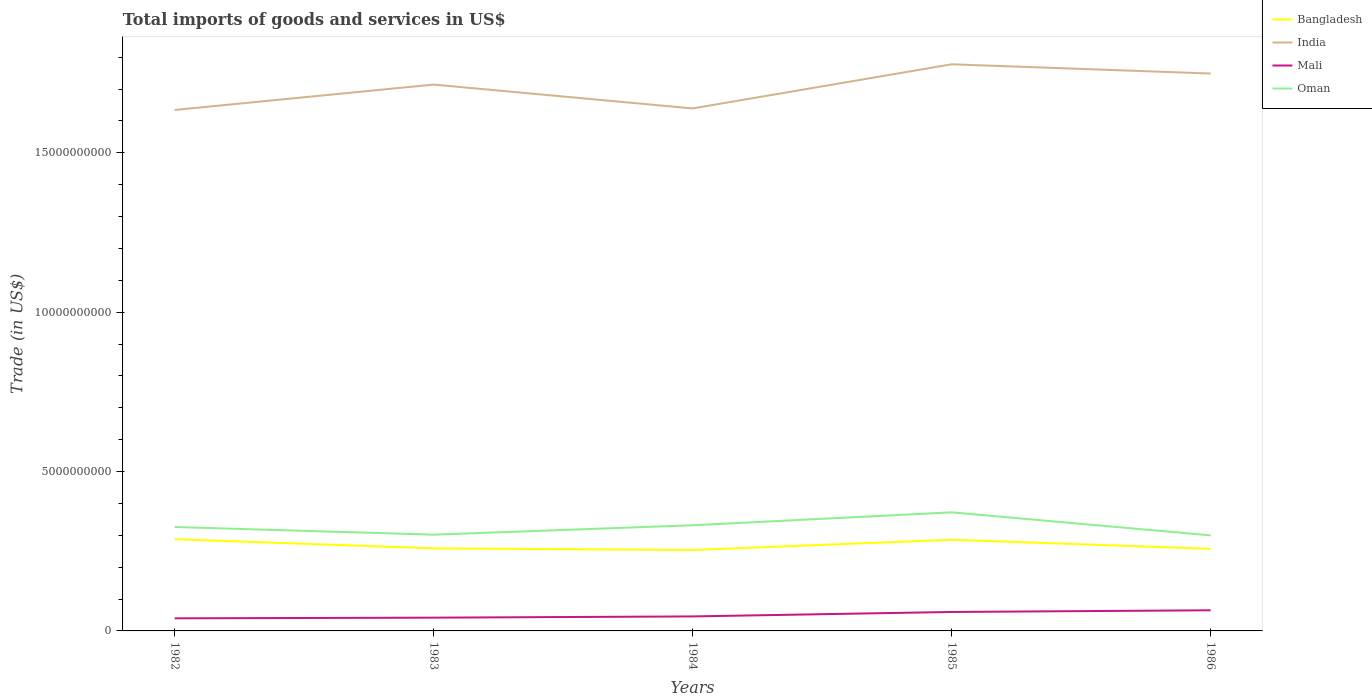Is the number of lines equal to the number of legend labels?
Offer a very short reply. Yes. Across all years, what is the maximum total imports of goods and services in Oman?
Offer a terse response. 3.00e+09. In which year was the total imports of goods and services in Mali maximum?
Your answer should be compact. 1982. What is the total total imports of goods and services in Oman in the graph?
Provide a short and direct response. 2.40e+08. What is the difference between the highest and the second highest total imports of goods and services in Mali?
Give a very brief answer. 2.52e+08. Is the total imports of goods and services in Oman strictly greater than the total imports of goods and services in Mali over the years?
Your answer should be very brief. No. Are the values on the major ticks of Y-axis written in scientific E-notation?
Your response must be concise. No. Where does the legend appear in the graph?
Your response must be concise. Top right. How many legend labels are there?
Provide a short and direct response. 4. What is the title of the graph?
Your answer should be compact. Total imports of goods and services in US$. What is the label or title of the Y-axis?
Provide a succinct answer. Trade (in US$). What is the Trade (in US$) of Bangladesh in 1982?
Your answer should be compact. 2.88e+09. What is the Trade (in US$) in India in 1982?
Your answer should be compact. 1.63e+1. What is the Trade (in US$) in Mali in 1982?
Your answer should be compact. 3.95e+08. What is the Trade (in US$) in Oman in 1982?
Ensure brevity in your answer.  3.26e+09. What is the Trade (in US$) of Bangladesh in 1983?
Your answer should be very brief. 2.59e+09. What is the Trade (in US$) in India in 1983?
Keep it short and to the point. 1.71e+1. What is the Trade (in US$) of Mali in 1983?
Keep it short and to the point. 4.16e+08. What is the Trade (in US$) of Oman in 1983?
Your answer should be compact. 3.02e+09. What is the Trade (in US$) in Bangladesh in 1984?
Your response must be concise. 2.54e+09. What is the Trade (in US$) of India in 1984?
Provide a succinct answer. 1.64e+1. What is the Trade (in US$) in Mali in 1984?
Offer a very short reply. 4.55e+08. What is the Trade (in US$) of Oman in 1984?
Provide a short and direct response. 3.32e+09. What is the Trade (in US$) in Bangladesh in 1985?
Keep it short and to the point. 2.86e+09. What is the Trade (in US$) in India in 1985?
Ensure brevity in your answer.  1.78e+1. What is the Trade (in US$) in Mali in 1985?
Your answer should be compact. 5.95e+08. What is the Trade (in US$) of Oman in 1985?
Give a very brief answer. 3.72e+09. What is the Trade (in US$) in Bangladesh in 1986?
Provide a succinct answer. 2.58e+09. What is the Trade (in US$) of India in 1986?
Provide a short and direct response. 1.75e+1. What is the Trade (in US$) of Mali in 1986?
Offer a terse response. 6.47e+08. What is the Trade (in US$) in Oman in 1986?
Give a very brief answer. 3.00e+09. Across all years, what is the maximum Trade (in US$) of Bangladesh?
Keep it short and to the point. 2.88e+09. Across all years, what is the maximum Trade (in US$) in India?
Keep it short and to the point. 1.78e+1. Across all years, what is the maximum Trade (in US$) in Mali?
Make the answer very short. 6.47e+08. Across all years, what is the maximum Trade (in US$) in Oman?
Ensure brevity in your answer.  3.72e+09. Across all years, what is the minimum Trade (in US$) of Bangladesh?
Provide a short and direct response. 2.54e+09. Across all years, what is the minimum Trade (in US$) of India?
Your answer should be compact. 1.63e+1. Across all years, what is the minimum Trade (in US$) of Mali?
Offer a terse response. 3.95e+08. Across all years, what is the minimum Trade (in US$) in Oman?
Ensure brevity in your answer.  3.00e+09. What is the total Trade (in US$) of Bangladesh in the graph?
Make the answer very short. 1.34e+1. What is the total Trade (in US$) of India in the graph?
Provide a short and direct response. 8.51e+1. What is the total Trade (in US$) in Mali in the graph?
Keep it short and to the point. 2.51e+09. What is the total Trade (in US$) in Oman in the graph?
Offer a very short reply. 1.63e+1. What is the difference between the Trade (in US$) of Bangladesh in 1982 and that in 1983?
Provide a short and direct response. 2.86e+08. What is the difference between the Trade (in US$) of India in 1982 and that in 1983?
Provide a succinct answer. -7.97e+08. What is the difference between the Trade (in US$) in Mali in 1982 and that in 1983?
Keep it short and to the point. -2.11e+07. What is the difference between the Trade (in US$) in Oman in 1982 and that in 1983?
Provide a short and direct response. 2.40e+08. What is the difference between the Trade (in US$) in Bangladesh in 1982 and that in 1984?
Ensure brevity in your answer.  3.39e+08. What is the difference between the Trade (in US$) in India in 1982 and that in 1984?
Make the answer very short. -4.78e+07. What is the difference between the Trade (in US$) in Mali in 1982 and that in 1984?
Your answer should be compact. -5.95e+07. What is the difference between the Trade (in US$) of Oman in 1982 and that in 1984?
Provide a short and direct response. -5.50e+07. What is the difference between the Trade (in US$) in Bangladesh in 1982 and that in 1985?
Your response must be concise. 1.73e+07. What is the difference between the Trade (in US$) of India in 1982 and that in 1985?
Your response must be concise. -1.43e+09. What is the difference between the Trade (in US$) in Mali in 1982 and that in 1985?
Provide a succinct answer. -1.99e+08. What is the difference between the Trade (in US$) of Oman in 1982 and that in 1985?
Keep it short and to the point. -4.60e+08. What is the difference between the Trade (in US$) in Bangladesh in 1982 and that in 1986?
Your answer should be very brief. 3.00e+08. What is the difference between the Trade (in US$) of India in 1982 and that in 1986?
Provide a succinct answer. -1.14e+09. What is the difference between the Trade (in US$) of Mali in 1982 and that in 1986?
Offer a very short reply. -2.52e+08. What is the difference between the Trade (in US$) of Oman in 1982 and that in 1986?
Give a very brief answer. 2.62e+08. What is the difference between the Trade (in US$) in Bangladesh in 1983 and that in 1984?
Your response must be concise. 5.25e+07. What is the difference between the Trade (in US$) in India in 1983 and that in 1984?
Give a very brief answer. 7.49e+08. What is the difference between the Trade (in US$) of Mali in 1983 and that in 1984?
Your response must be concise. -3.83e+07. What is the difference between the Trade (in US$) of Oman in 1983 and that in 1984?
Your response must be concise. -2.95e+08. What is the difference between the Trade (in US$) in Bangladesh in 1983 and that in 1985?
Ensure brevity in your answer.  -2.69e+08. What is the difference between the Trade (in US$) in India in 1983 and that in 1985?
Ensure brevity in your answer.  -6.37e+08. What is the difference between the Trade (in US$) in Mali in 1983 and that in 1985?
Your response must be concise. -1.78e+08. What is the difference between the Trade (in US$) in Oman in 1983 and that in 1985?
Your response must be concise. -7.01e+08. What is the difference between the Trade (in US$) in Bangladesh in 1983 and that in 1986?
Your response must be concise. 1.37e+07. What is the difference between the Trade (in US$) of India in 1983 and that in 1986?
Keep it short and to the point. -3.46e+08. What is the difference between the Trade (in US$) of Mali in 1983 and that in 1986?
Provide a succinct answer. -2.31e+08. What is the difference between the Trade (in US$) of Oman in 1983 and that in 1986?
Offer a terse response. 2.22e+07. What is the difference between the Trade (in US$) in Bangladesh in 1984 and that in 1985?
Provide a succinct answer. -3.22e+08. What is the difference between the Trade (in US$) of India in 1984 and that in 1985?
Provide a short and direct response. -1.39e+09. What is the difference between the Trade (in US$) in Mali in 1984 and that in 1985?
Your answer should be compact. -1.40e+08. What is the difference between the Trade (in US$) in Oman in 1984 and that in 1985?
Provide a short and direct response. -4.05e+08. What is the difference between the Trade (in US$) of Bangladesh in 1984 and that in 1986?
Provide a succinct answer. -3.88e+07. What is the difference between the Trade (in US$) of India in 1984 and that in 1986?
Offer a terse response. -1.10e+09. What is the difference between the Trade (in US$) in Mali in 1984 and that in 1986?
Ensure brevity in your answer.  -1.93e+08. What is the difference between the Trade (in US$) of Oman in 1984 and that in 1986?
Your response must be concise. 3.18e+08. What is the difference between the Trade (in US$) in Bangladesh in 1985 and that in 1986?
Ensure brevity in your answer.  2.83e+08. What is the difference between the Trade (in US$) in India in 1985 and that in 1986?
Offer a very short reply. 2.90e+08. What is the difference between the Trade (in US$) of Mali in 1985 and that in 1986?
Ensure brevity in your answer.  -5.28e+07. What is the difference between the Trade (in US$) of Oman in 1985 and that in 1986?
Keep it short and to the point. 7.23e+08. What is the difference between the Trade (in US$) of Bangladesh in 1982 and the Trade (in US$) of India in 1983?
Give a very brief answer. -1.43e+1. What is the difference between the Trade (in US$) in Bangladesh in 1982 and the Trade (in US$) in Mali in 1983?
Ensure brevity in your answer.  2.46e+09. What is the difference between the Trade (in US$) of Bangladesh in 1982 and the Trade (in US$) of Oman in 1983?
Your answer should be compact. -1.42e+08. What is the difference between the Trade (in US$) of India in 1982 and the Trade (in US$) of Mali in 1983?
Provide a short and direct response. 1.59e+1. What is the difference between the Trade (in US$) of India in 1982 and the Trade (in US$) of Oman in 1983?
Keep it short and to the point. 1.33e+1. What is the difference between the Trade (in US$) of Mali in 1982 and the Trade (in US$) of Oman in 1983?
Your answer should be very brief. -2.62e+09. What is the difference between the Trade (in US$) of Bangladesh in 1982 and the Trade (in US$) of India in 1984?
Keep it short and to the point. -1.35e+1. What is the difference between the Trade (in US$) of Bangladesh in 1982 and the Trade (in US$) of Mali in 1984?
Give a very brief answer. 2.42e+09. What is the difference between the Trade (in US$) in Bangladesh in 1982 and the Trade (in US$) in Oman in 1984?
Your answer should be compact. -4.38e+08. What is the difference between the Trade (in US$) in India in 1982 and the Trade (in US$) in Mali in 1984?
Provide a short and direct response. 1.59e+1. What is the difference between the Trade (in US$) in India in 1982 and the Trade (in US$) in Oman in 1984?
Your answer should be very brief. 1.30e+1. What is the difference between the Trade (in US$) of Mali in 1982 and the Trade (in US$) of Oman in 1984?
Provide a short and direct response. -2.92e+09. What is the difference between the Trade (in US$) in Bangladesh in 1982 and the Trade (in US$) in India in 1985?
Offer a terse response. -1.49e+1. What is the difference between the Trade (in US$) in Bangladesh in 1982 and the Trade (in US$) in Mali in 1985?
Ensure brevity in your answer.  2.28e+09. What is the difference between the Trade (in US$) of Bangladesh in 1982 and the Trade (in US$) of Oman in 1985?
Provide a short and direct response. -8.43e+08. What is the difference between the Trade (in US$) of India in 1982 and the Trade (in US$) of Mali in 1985?
Offer a terse response. 1.57e+1. What is the difference between the Trade (in US$) of India in 1982 and the Trade (in US$) of Oman in 1985?
Provide a short and direct response. 1.26e+1. What is the difference between the Trade (in US$) of Mali in 1982 and the Trade (in US$) of Oman in 1985?
Your response must be concise. -3.33e+09. What is the difference between the Trade (in US$) of Bangladesh in 1982 and the Trade (in US$) of India in 1986?
Offer a very short reply. -1.46e+1. What is the difference between the Trade (in US$) of Bangladesh in 1982 and the Trade (in US$) of Mali in 1986?
Offer a terse response. 2.23e+09. What is the difference between the Trade (in US$) of Bangladesh in 1982 and the Trade (in US$) of Oman in 1986?
Your answer should be very brief. -1.20e+08. What is the difference between the Trade (in US$) of India in 1982 and the Trade (in US$) of Mali in 1986?
Ensure brevity in your answer.  1.57e+1. What is the difference between the Trade (in US$) in India in 1982 and the Trade (in US$) in Oman in 1986?
Make the answer very short. 1.33e+1. What is the difference between the Trade (in US$) of Mali in 1982 and the Trade (in US$) of Oman in 1986?
Your response must be concise. -2.60e+09. What is the difference between the Trade (in US$) in Bangladesh in 1983 and the Trade (in US$) in India in 1984?
Keep it short and to the point. -1.38e+1. What is the difference between the Trade (in US$) in Bangladesh in 1983 and the Trade (in US$) in Mali in 1984?
Give a very brief answer. 2.14e+09. What is the difference between the Trade (in US$) in Bangladesh in 1983 and the Trade (in US$) in Oman in 1984?
Provide a succinct answer. -7.24e+08. What is the difference between the Trade (in US$) in India in 1983 and the Trade (in US$) in Mali in 1984?
Provide a short and direct response. 1.67e+1. What is the difference between the Trade (in US$) in India in 1983 and the Trade (in US$) in Oman in 1984?
Your response must be concise. 1.38e+1. What is the difference between the Trade (in US$) in Mali in 1983 and the Trade (in US$) in Oman in 1984?
Ensure brevity in your answer.  -2.90e+09. What is the difference between the Trade (in US$) in Bangladesh in 1983 and the Trade (in US$) in India in 1985?
Provide a succinct answer. -1.52e+1. What is the difference between the Trade (in US$) of Bangladesh in 1983 and the Trade (in US$) of Mali in 1985?
Make the answer very short. 2.00e+09. What is the difference between the Trade (in US$) in Bangladesh in 1983 and the Trade (in US$) in Oman in 1985?
Your answer should be very brief. -1.13e+09. What is the difference between the Trade (in US$) of India in 1983 and the Trade (in US$) of Mali in 1985?
Your response must be concise. 1.65e+1. What is the difference between the Trade (in US$) of India in 1983 and the Trade (in US$) of Oman in 1985?
Your response must be concise. 1.34e+1. What is the difference between the Trade (in US$) of Mali in 1983 and the Trade (in US$) of Oman in 1985?
Make the answer very short. -3.30e+09. What is the difference between the Trade (in US$) in Bangladesh in 1983 and the Trade (in US$) in India in 1986?
Give a very brief answer. -1.49e+1. What is the difference between the Trade (in US$) in Bangladesh in 1983 and the Trade (in US$) in Mali in 1986?
Your answer should be very brief. 1.94e+09. What is the difference between the Trade (in US$) of Bangladesh in 1983 and the Trade (in US$) of Oman in 1986?
Make the answer very short. -4.07e+08. What is the difference between the Trade (in US$) of India in 1983 and the Trade (in US$) of Mali in 1986?
Give a very brief answer. 1.65e+1. What is the difference between the Trade (in US$) of India in 1983 and the Trade (in US$) of Oman in 1986?
Offer a terse response. 1.41e+1. What is the difference between the Trade (in US$) in Mali in 1983 and the Trade (in US$) in Oman in 1986?
Ensure brevity in your answer.  -2.58e+09. What is the difference between the Trade (in US$) in Bangladesh in 1984 and the Trade (in US$) in India in 1985?
Keep it short and to the point. -1.52e+1. What is the difference between the Trade (in US$) of Bangladesh in 1984 and the Trade (in US$) of Mali in 1985?
Offer a terse response. 1.94e+09. What is the difference between the Trade (in US$) in Bangladesh in 1984 and the Trade (in US$) in Oman in 1985?
Give a very brief answer. -1.18e+09. What is the difference between the Trade (in US$) of India in 1984 and the Trade (in US$) of Mali in 1985?
Provide a succinct answer. 1.58e+1. What is the difference between the Trade (in US$) in India in 1984 and the Trade (in US$) in Oman in 1985?
Provide a short and direct response. 1.27e+1. What is the difference between the Trade (in US$) in Mali in 1984 and the Trade (in US$) in Oman in 1985?
Give a very brief answer. -3.27e+09. What is the difference between the Trade (in US$) of Bangladesh in 1984 and the Trade (in US$) of India in 1986?
Provide a succinct answer. -1.49e+1. What is the difference between the Trade (in US$) in Bangladesh in 1984 and the Trade (in US$) in Mali in 1986?
Keep it short and to the point. 1.89e+09. What is the difference between the Trade (in US$) of Bangladesh in 1984 and the Trade (in US$) of Oman in 1986?
Your answer should be compact. -4.59e+08. What is the difference between the Trade (in US$) in India in 1984 and the Trade (in US$) in Mali in 1986?
Provide a succinct answer. 1.57e+1. What is the difference between the Trade (in US$) in India in 1984 and the Trade (in US$) in Oman in 1986?
Offer a very short reply. 1.34e+1. What is the difference between the Trade (in US$) in Mali in 1984 and the Trade (in US$) in Oman in 1986?
Provide a succinct answer. -2.54e+09. What is the difference between the Trade (in US$) of Bangladesh in 1985 and the Trade (in US$) of India in 1986?
Ensure brevity in your answer.  -1.46e+1. What is the difference between the Trade (in US$) in Bangladesh in 1985 and the Trade (in US$) in Mali in 1986?
Ensure brevity in your answer.  2.21e+09. What is the difference between the Trade (in US$) of Bangladesh in 1985 and the Trade (in US$) of Oman in 1986?
Give a very brief answer. -1.37e+08. What is the difference between the Trade (in US$) of India in 1985 and the Trade (in US$) of Mali in 1986?
Your answer should be compact. 1.71e+1. What is the difference between the Trade (in US$) of India in 1985 and the Trade (in US$) of Oman in 1986?
Provide a succinct answer. 1.48e+1. What is the difference between the Trade (in US$) of Mali in 1985 and the Trade (in US$) of Oman in 1986?
Ensure brevity in your answer.  -2.40e+09. What is the average Trade (in US$) in Bangladesh per year?
Your response must be concise. 2.69e+09. What is the average Trade (in US$) of India per year?
Your answer should be very brief. 1.70e+1. What is the average Trade (in US$) in Mali per year?
Offer a terse response. 5.02e+08. What is the average Trade (in US$) of Oman per year?
Provide a succinct answer. 3.26e+09. In the year 1982, what is the difference between the Trade (in US$) of Bangladesh and Trade (in US$) of India?
Keep it short and to the point. -1.35e+1. In the year 1982, what is the difference between the Trade (in US$) in Bangladesh and Trade (in US$) in Mali?
Your response must be concise. 2.48e+09. In the year 1982, what is the difference between the Trade (in US$) in Bangladesh and Trade (in US$) in Oman?
Your answer should be very brief. -3.83e+08. In the year 1982, what is the difference between the Trade (in US$) in India and Trade (in US$) in Mali?
Provide a short and direct response. 1.59e+1. In the year 1982, what is the difference between the Trade (in US$) of India and Trade (in US$) of Oman?
Make the answer very short. 1.31e+1. In the year 1982, what is the difference between the Trade (in US$) in Mali and Trade (in US$) in Oman?
Provide a short and direct response. -2.86e+09. In the year 1983, what is the difference between the Trade (in US$) in Bangladesh and Trade (in US$) in India?
Provide a short and direct response. -1.45e+1. In the year 1983, what is the difference between the Trade (in US$) in Bangladesh and Trade (in US$) in Mali?
Your response must be concise. 2.17e+09. In the year 1983, what is the difference between the Trade (in US$) in Bangladesh and Trade (in US$) in Oman?
Offer a very short reply. -4.29e+08. In the year 1983, what is the difference between the Trade (in US$) of India and Trade (in US$) of Mali?
Offer a very short reply. 1.67e+1. In the year 1983, what is the difference between the Trade (in US$) of India and Trade (in US$) of Oman?
Ensure brevity in your answer.  1.41e+1. In the year 1983, what is the difference between the Trade (in US$) of Mali and Trade (in US$) of Oman?
Your answer should be very brief. -2.60e+09. In the year 1984, what is the difference between the Trade (in US$) of Bangladesh and Trade (in US$) of India?
Give a very brief answer. -1.39e+1. In the year 1984, what is the difference between the Trade (in US$) of Bangladesh and Trade (in US$) of Mali?
Make the answer very short. 2.08e+09. In the year 1984, what is the difference between the Trade (in US$) of Bangladesh and Trade (in US$) of Oman?
Your answer should be compact. -7.77e+08. In the year 1984, what is the difference between the Trade (in US$) in India and Trade (in US$) in Mali?
Make the answer very short. 1.59e+1. In the year 1984, what is the difference between the Trade (in US$) of India and Trade (in US$) of Oman?
Your answer should be very brief. 1.31e+1. In the year 1984, what is the difference between the Trade (in US$) of Mali and Trade (in US$) of Oman?
Ensure brevity in your answer.  -2.86e+09. In the year 1985, what is the difference between the Trade (in US$) of Bangladesh and Trade (in US$) of India?
Offer a terse response. -1.49e+1. In the year 1985, what is the difference between the Trade (in US$) of Bangladesh and Trade (in US$) of Mali?
Make the answer very short. 2.27e+09. In the year 1985, what is the difference between the Trade (in US$) of Bangladesh and Trade (in US$) of Oman?
Ensure brevity in your answer.  -8.60e+08. In the year 1985, what is the difference between the Trade (in US$) in India and Trade (in US$) in Mali?
Your answer should be very brief. 1.72e+1. In the year 1985, what is the difference between the Trade (in US$) of India and Trade (in US$) of Oman?
Make the answer very short. 1.41e+1. In the year 1985, what is the difference between the Trade (in US$) of Mali and Trade (in US$) of Oman?
Provide a short and direct response. -3.13e+09. In the year 1986, what is the difference between the Trade (in US$) in Bangladesh and Trade (in US$) in India?
Offer a very short reply. -1.49e+1. In the year 1986, what is the difference between the Trade (in US$) of Bangladesh and Trade (in US$) of Mali?
Keep it short and to the point. 1.93e+09. In the year 1986, what is the difference between the Trade (in US$) of Bangladesh and Trade (in US$) of Oman?
Keep it short and to the point. -4.20e+08. In the year 1986, what is the difference between the Trade (in US$) in India and Trade (in US$) in Mali?
Provide a short and direct response. 1.68e+1. In the year 1986, what is the difference between the Trade (in US$) in India and Trade (in US$) in Oman?
Ensure brevity in your answer.  1.45e+1. In the year 1986, what is the difference between the Trade (in US$) of Mali and Trade (in US$) of Oman?
Make the answer very short. -2.35e+09. What is the ratio of the Trade (in US$) of Bangladesh in 1982 to that in 1983?
Make the answer very short. 1.11. What is the ratio of the Trade (in US$) of India in 1982 to that in 1983?
Provide a succinct answer. 0.95. What is the ratio of the Trade (in US$) in Mali in 1982 to that in 1983?
Provide a succinct answer. 0.95. What is the ratio of the Trade (in US$) of Oman in 1982 to that in 1983?
Your answer should be very brief. 1.08. What is the ratio of the Trade (in US$) of Bangladesh in 1982 to that in 1984?
Offer a terse response. 1.13. What is the ratio of the Trade (in US$) in India in 1982 to that in 1984?
Make the answer very short. 1. What is the ratio of the Trade (in US$) of Mali in 1982 to that in 1984?
Provide a succinct answer. 0.87. What is the ratio of the Trade (in US$) in Oman in 1982 to that in 1984?
Ensure brevity in your answer.  0.98. What is the ratio of the Trade (in US$) in India in 1982 to that in 1985?
Provide a short and direct response. 0.92. What is the ratio of the Trade (in US$) of Mali in 1982 to that in 1985?
Provide a succinct answer. 0.66. What is the ratio of the Trade (in US$) of Oman in 1982 to that in 1985?
Offer a terse response. 0.88. What is the ratio of the Trade (in US$) of Bangladesh in 1982 to that in 1986?
Your response must be concise. 1.12. What is the ratio of the Trade (in US$) of India in 1982 to that in 1986?
Your response must be concise. 0.93. What is the ratio of the Trade (in US$) of Mali in 1982 to that in 1986?
Offer a terse response. 0.61. What is the ratio of the Trade (in US$) of Oman in 1982 to that in 1986?
Offer a terse response. 1.09. What is the ratio of the Trade (in US$) of Bangladesh in 1983 to that in 1984?
Keep it short and to the point. 1.02. What is the ratio of the Trade (in US$) in India in 1983 to that in 1984?
Ensure brevity in your answer.  1.05. What is the ratio of the Trade (in US$) in Mali in 1983 to that in 1984?
Ensure brevity in your answer.  0.92. What is the ratio of the Trade (in US$) in Oman in 1983 to that in 1984?
Your response must be concise. 0.91. What is the ratio of the Trade (in US$) in Bangladesh in 1983 to that in 1985?
Your answer should be very brief. 0.91. What is the ratio of the Trade (in US$) of India in 1983 to that in 1985?
Keep it short and to the point. 0.96. What is the ratio of the Trade (in US$) in Mali in 1983 to that in 1985?
Your answer should be compact. 0.7. What is the ratio of the Trade (in US$) in Oman in 1983 to that in 1985?
Ensure brevity in your answer.  0.81. What is the ratio of the Trade (in US$) of Bangladesh in 1983 to that in 1986?
Your response must be concise. 1.01. What is the ratio of the Trade (in US$) in India in 1983 to that in 1986?
Provide a succinct answer. 0.98. What is the ratio of the Trade (in US$) of Mali in 1983 to that in 1986?
Make the answer very short. 0.64. What is the ratio of the Trade (in US$) in Oman in 1983 to that in 1986?
Make the answer very short. 1.01. What is the ratio of the Trade (in US$) in Bangladesh in 1984 to that in 1985?
Give a very brief answer. 0.89. What is the ratio of the Trade (in US$) of India in 1984 to that in 1985?
Provide a succinct answer. 0.92. What is the ratio of the Trade (in US$) in Mali in 1984 to that in 1985?
Make the answer very short. 0.76. What is the ratio of the Trade (in US$) of Oman in 1984 to that in 1985?
Ensure brevity in your answer.  0.89. What is the ratio of the Trade (in US$) in Bangladesh in 1984 to that in 1986?
Your answer should be very brief. 0.98. What is the ratio of the Trade (in US$) of India in 1984 to that in 1986?
Make the answer very short. 0.94. What is the ratio of the Trade (in US$) in Mali in 1984 to that in 1986?
Your response must be concise. 0.7. What is the ratio of the Trade (in US$) of Oman in 1984 to that in 1986?
Your answer should be compact. 1.11. What is the ratio of the Trade (in US$) of Bangladesh in 1985 to that in 1986?
Offer a very short reply. 1.11. What is the ratio of the Trade (in US$) in India in 1985 to that in 1986?
Give a very brief answer. 1.02. What is the ratio of the Trade (in US$) of Mali in 1985 to that in 1986?
Offer a very short reply. 0.92. What is the ratio of the Trade (in US$) of Oman in 1985 to that in 1986?
Your response must be concise. 1.24. What is the difference between the highest and the second highest Trade (in US$) of Bangladesh?
Offer a very short reply. 1.73e+07. What is the difference between the highest and the second highest Trade (in US$) of India?
Make the answer very short. 2.90e+08. What is the difference between the highest and the second highest Trade (in US$) of Mali?
Make the answer very short. 5.28e+07. What is the difference between the highest and the second highest Trade (in US$) in Oman?
Ensure brevity in your answer.  4.05e+08. What is the difference between the highest and the lowest Trade (in US$) in Bangladesh?
Offer a very short reply. 3.39e+08. What is the difference between the highest and the lowest Trade (in US$) in India?
Your response must be concise. 1.43e+09. What is the difference between the highest and the lowest Trade (in US$) in Mali?
Ensure brevity in your answer.  2.52e+08. What is the difference between the highest and the lowest Trade (in US$) in Oman?
Your response must be concise. 7.23e+08. 